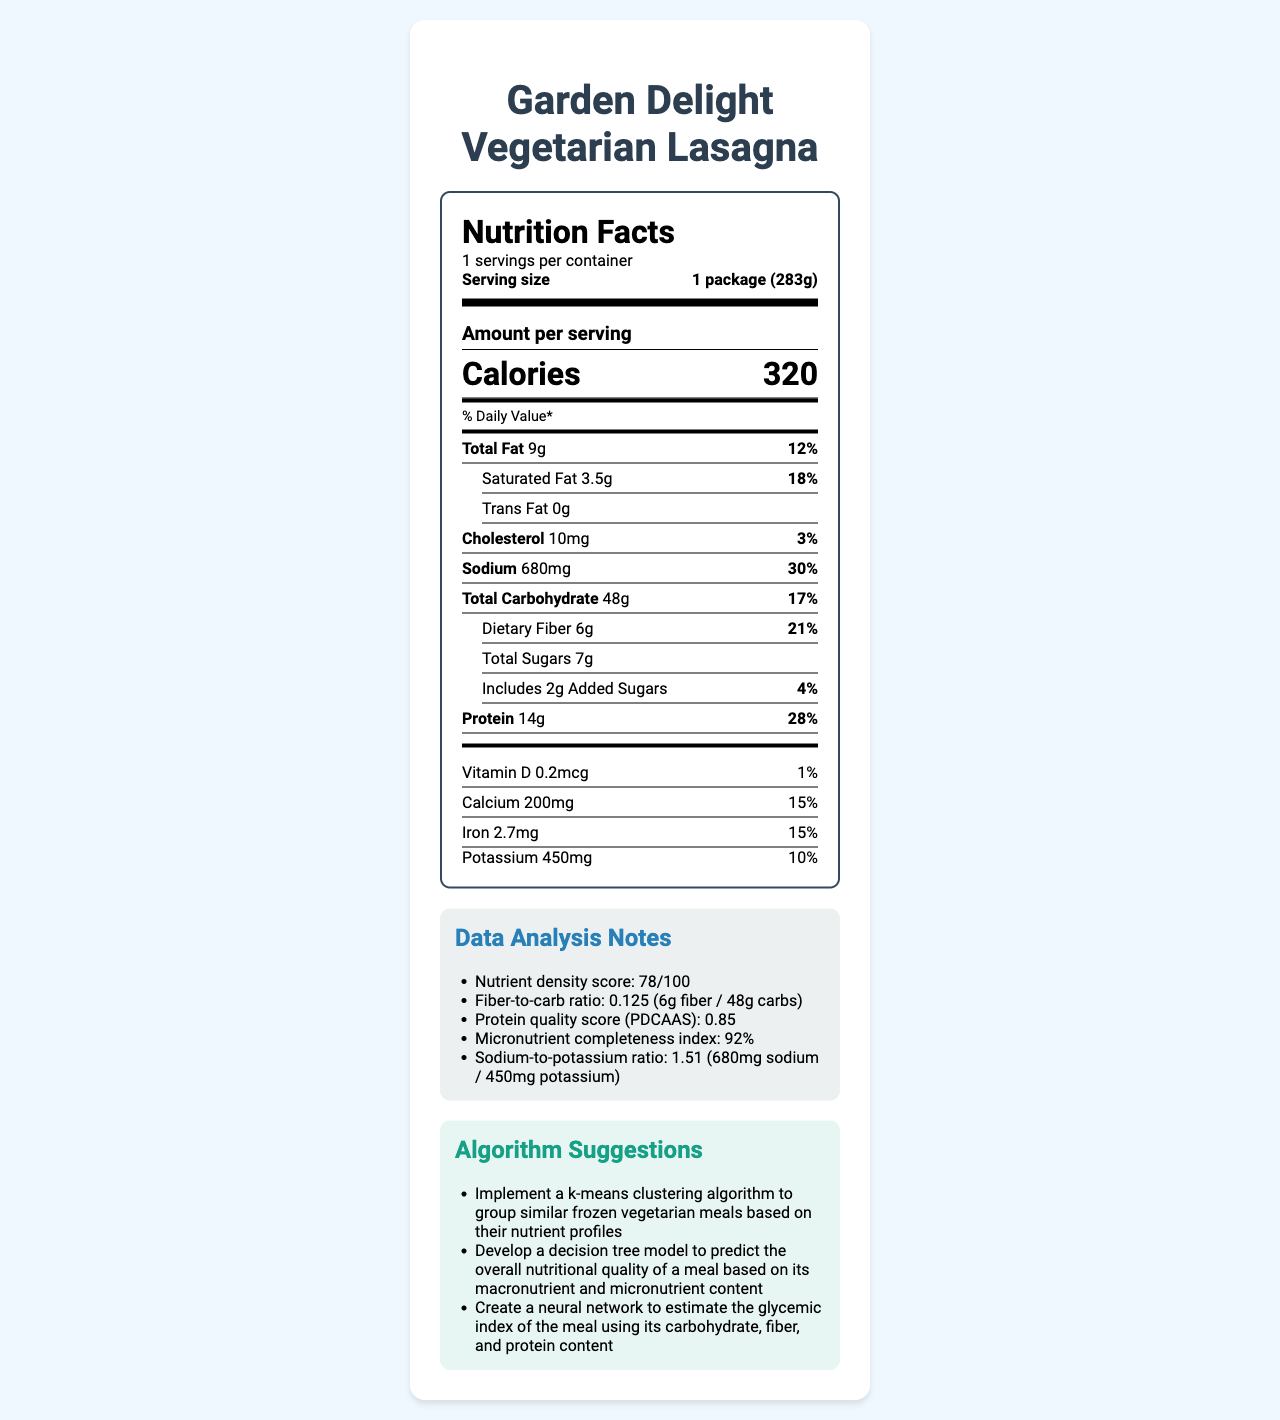what is the serving size of the Garden Delight Vegetarian Lasagna? The document states that the serving size is "1 package (283g)" in the label header section.
Answer: 1 package (283g) how many calories are in one serving? The document lists the amount of calories per serving as 320 in the "Amount per serving" section.
Answer: 320 what percentage of the daily recommended intake of dietary fiber does one serving provide? The document indicates that the dietary fiber content is 21% of the daily value for one serving.
Answer: 21% which vitamin has the highest daily value percentage per serving of Garden Delight Vegetarian Lasagna? The document shows that Riboflavin has the highest daily value percentage at 30%.
Answer: Riboflavin (30%) how much sodium is in one serving? The amount of sodium per serving is listed as 680mg in the section describing the nutrients.
Answer: 680mg what is the nutrient density score of the Garden Delight Vegetarian Lasagna? In the "Data Analysis Notes" section, the nutrient density score is mentioned as 78/100.
Answer: 78/100 how much total fat does one serving of this product contain? The document specifies that the total fat content per serving is 9g.
Answer: 9g how much protein does one serving provide? The protein content per serving is listed as 14g in the nutrient details.
Answer: 14g which of the following is NOT a component of the document's "Algorithm Suggestions"? 1. Implement a k-means clustering algorithm 2. Develop a decision tree model 3. Create a random forest model 4. Create a neural network The "Algorithm Suggestions" section lists three suggestions: 1. Implement a k-means clustering algorithm, 2. Develop a decision tree model, and 4. Create a neural network. Option 3 is not mentioned.
Answer: 3. Create a random forest model how much added sugars are in one serving of the product? The label under "Includes Added Sugars" shows an amount of 2g for added sugars per serving.
Answer: 2g does the product contain any trans fat? The document states under "Trans Fat" that the amount is 0g, indicating that there is no trans fat in the product.
Answer: No what is the main idea of the document? The document is essentially a comprehensive Nutrition Facts Label for a vegetarian frozen dinner named Garden Delight Vegetarian Lasagna. It includes detailed breakdowns of macronutrients, micronutrients, fiber content, and additional analysis.
Answer: The document provides the Nutrition Facts Label for Garden Delight Vegetarian Lasagna, detailing its nutrient content, daily values, data analysis insights, and algorithm suggestions. is the sodium-to-potassium ratio of this product above 1? The "Data Analysis Notes" section specifies that the sodium-to-potassium ratio is 1.51, which is above 1.
Answer: Yes how many grams of dietary fiber are in one serving? The document states that there are 6 grams of dietary fiber per serving.
Answer: 6g what is the suggested daily value percentage of vitamin K in the lasagna? A. 10% B. 20% C. 30% D. 40% The specified daily value percentage of vitamin K in the document is 20%.
Answer: B. 20% which mineral content listed is under 10% of the daily value? According to the "Nutrient analysis" section, chloride is 6% of the daily value, below the 10% threshold.
Answer: Chloride (6%) how much calcium does one serving of the product provide? The amount of calcium per serving is 200mg, as listed under "Nutrient analysis" in the document.
Answer: 200mg is the protein quality score (PDCAAS) for this product higher than 0.9? The "Data Analysis Notes" mentions that the Protein Quality Score (PDCAAS) is 0.85, which is less than 0.9.
Answer: No how much vitamin C is in one serving, and what is its daily value percentage? The document notes that one serving contains 15mg of vitamin C, which is 17% of the daily value.
Answer: 15mg, 17% what is the recommendation for utilizing machine learning in the analysis of the nutritional quality of meals? Under "Algorithm Suggestions," the document recommends developing a decision tree model to predict the overall nutritional quality of a meal.
Answer: Develop a decision tree model 